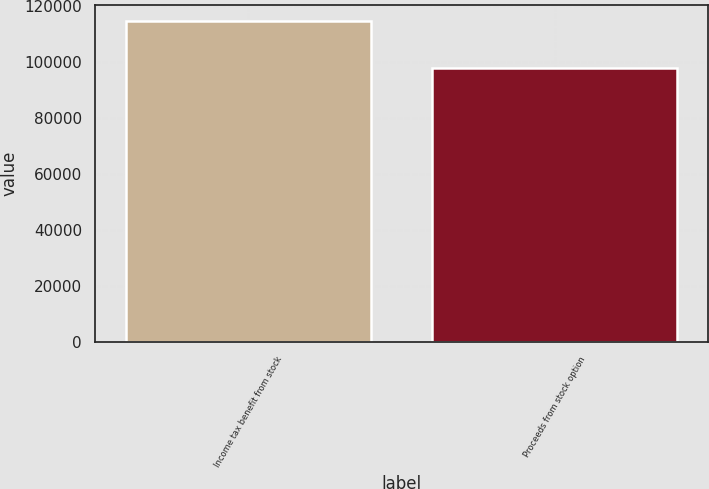Convert chart to OTSL. <chart><loc_0><loc_0><loc_500><loc_500><bar_chart><fcel>Income tax benefit from stock<fcel>Proceeds from stock option<nl><fcel>114641<fcel>97792<nl></chart> 